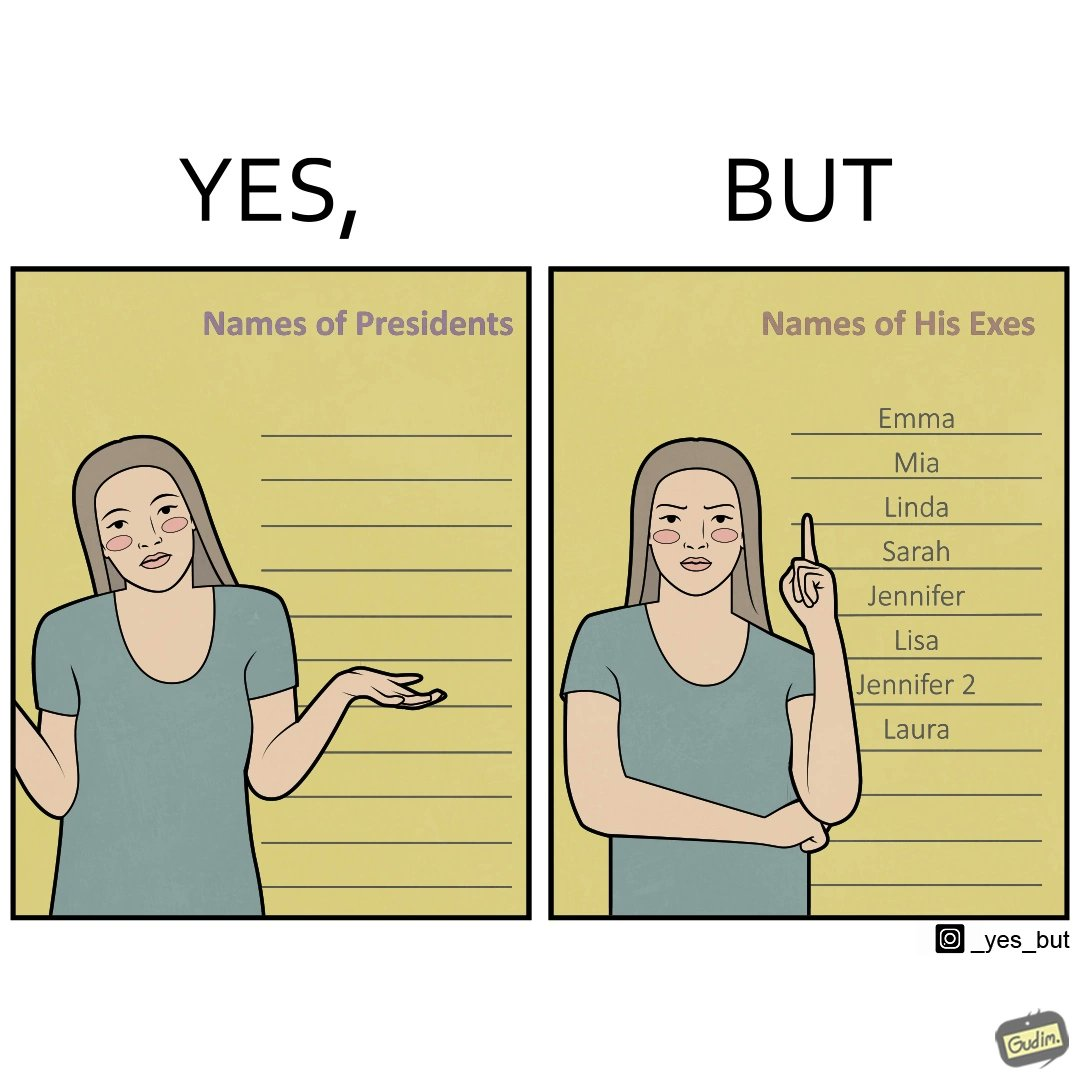What does this image depict? The images are funny since it shows how people tend to forget the important details like names of presidents but remember the useless ones, like forgetting names of presidents but remembering the names of their exes in this example 